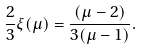Convert formula to latex. <formula><loc_0><loc_0><loc_500><loc_500>\frac { 2 } { 3 } \xi ( \mu ) = \frac { ( \mu - 2 ) } { 3 ( \mu - 1 ) } .</formula> 